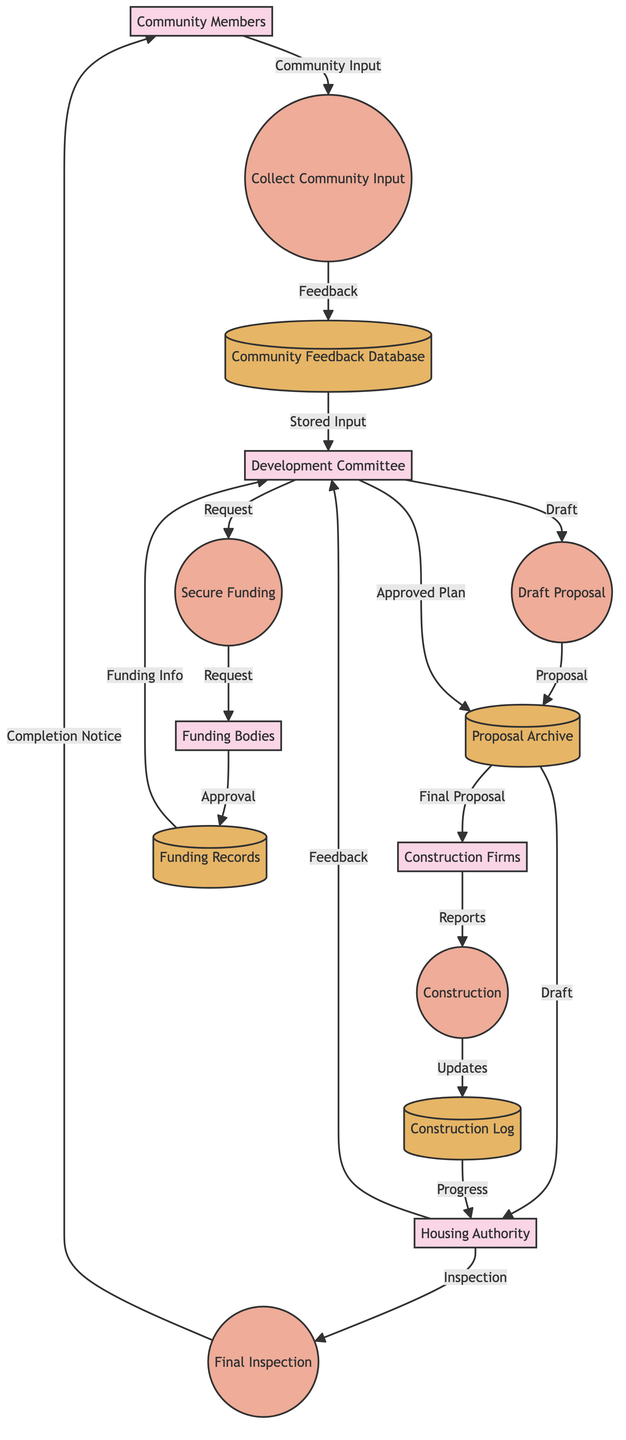What is the first process in the diagram? The diagram starts with the process "Collect Community Input," which is the first step in the housing development process. This information can be identified at the top of the flowchart where the sequence begins.
Answer: Collect Community Input How many entities are present in the diagram? To determine the number of entities, count the distinct entities listed: Community Members, Housing Authority, Development Committee, Funding Bodies, and Construction Firms, which totals five entities.
Answer: Five What is the relationship between the Development Committee and the Housing Authority? The Development Committee provides a "Draft Proposal" to the Housing Authority, which reviews it and returns "Proposal Feedback." This relationship indicates a two-way communication between these two nodes.
Answer: Draft Proposal What type of data flow comes from the Funding Bodies? The Funding Bodies provide "Funding Approval" back to the Development Committee after the funding request is made, representing a direct response in the data flow.
Answer: Funding Approval Which process follows the "Secure Funding" process? After "Secure Funding," the next process is "Proposal Approval," indicating the sequence of activities that occurs after funding is obtained. This is derived from the flowchart order.
Answer: Proposal Approval What is stored in the Community Feedback Database? The Community Feedback Database stores the "Stored Input," which contains feedback gathered from the community members throughout the initial input collection process. This can be inferred from the data flow connections.
Answer: Stored Input How many data stores are identified in the diagram? The diagram indicates four data stores: Community Feedback Database, Proposal Archive, Funding Records, and Construction Log. Counting these reveals there are four distinct databases or repositories.
Answer: Four Which entity is responsible for conducting the final inspection? The Housing Authority is responsible for conducting the "Final Inspection," as indicated by the flow that shows this entity assessing the completed construction. This role is primarily linked to the process at the end of the development cycle.
Answer: Housing Authority What is communicated to Community Members at the end of the process? At the end of the development process, the Housing Authority communicates the "Project Completion Notice" to the Community Members, indicating the conclusion of the housing development process.
Answer: Project Completion Notice Which process handles the actual construction of housing? The "Construction" process handles the actual development of housing units, as designated in the diagram and connected directly to the Construction Firms entity. This process is a critical step in the diagram's workflow.
Answer: Construction 